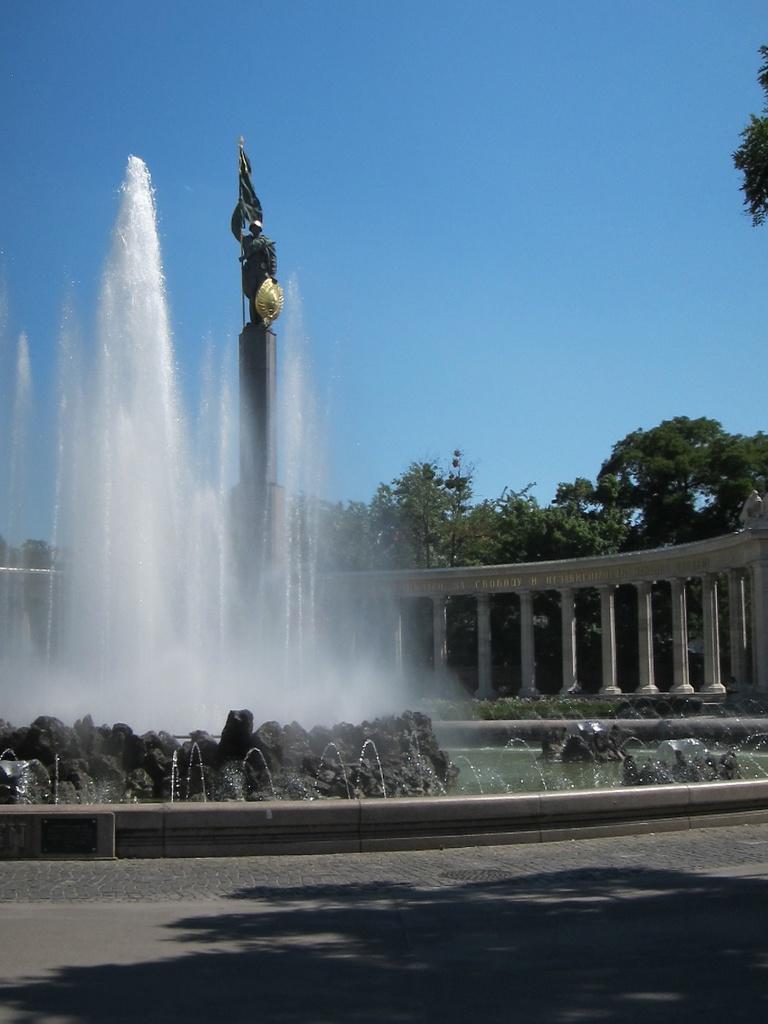In one or two sentences, can you explain what this image depicts? In this image I can see a shadow on the road. In the background I can see the water fountain, a sculpture, number of pillars, number of trees and the sky. 